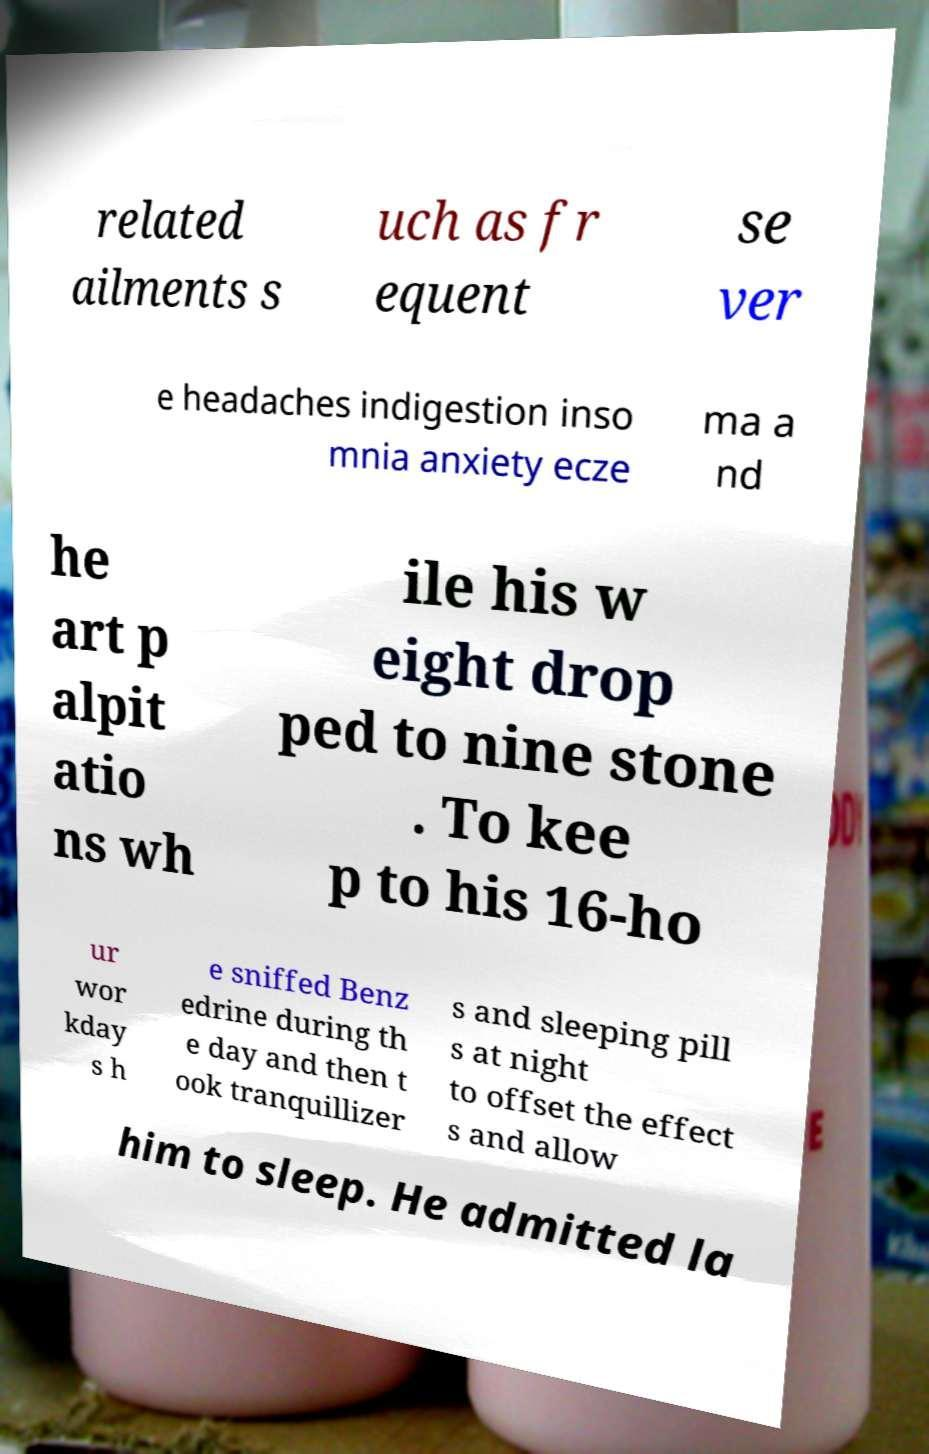Can you accurately transcribe the text from the provided image for me? related ailments s uch as fr equent se ver e headaches indigestion inso mnia anxiety ecze ma a nd he art p alpit atio ns wh ile his w eight drop ped to nine stone . To kee p to his 16-ho ur wor kday s h e sniffed Benz edrine during th e day and then t ook tranquillizer s and sleeping pill s at night to offset the effect s and allow him to sleep. He admitted la 